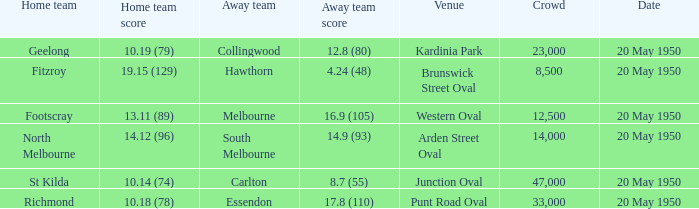Could you parse the entire table as a dict? {'header': ['Home team', 'Home team score', 'Away team', 'Away team score', 'Venue', 'Crowd', 'Date'], 'rows': [['Geelong', '10.19 (79)', 'Collingwood', '12.8 (80)', 'Kardinia Park', '23,000', '20 May 1950'], ['Fitzroy', '19.15 (129)', 'Hawthorn', '4.24 (48)', 'Brunswick Street Oval', '8,500', '20 May 1950'], ['Footscray', '13.11 (89)', 'Melbourne', '16.9 (105)', 'Western Oval', '12,500', '20 May 1950'], ['North Melbourne', '14.12 (96)', 'South Melbourne', '14.9 (93)', 'Arden Street Oval', '14,000', '20 May 1950'], ['St Kilda', '10.14 (74)', 'Carlton', '8.7 (55)', 'Junction Oval', '47,000', '20 May 1950'], ['Richmond', '10.18 (78)', 'Essendon', '17.8 (110)', 'Punt Road Oval', '33,000', '20 May 1950']]} What was the score for the away team that played against Richmond and has a crowd over 12,500? 17.8 (110). 